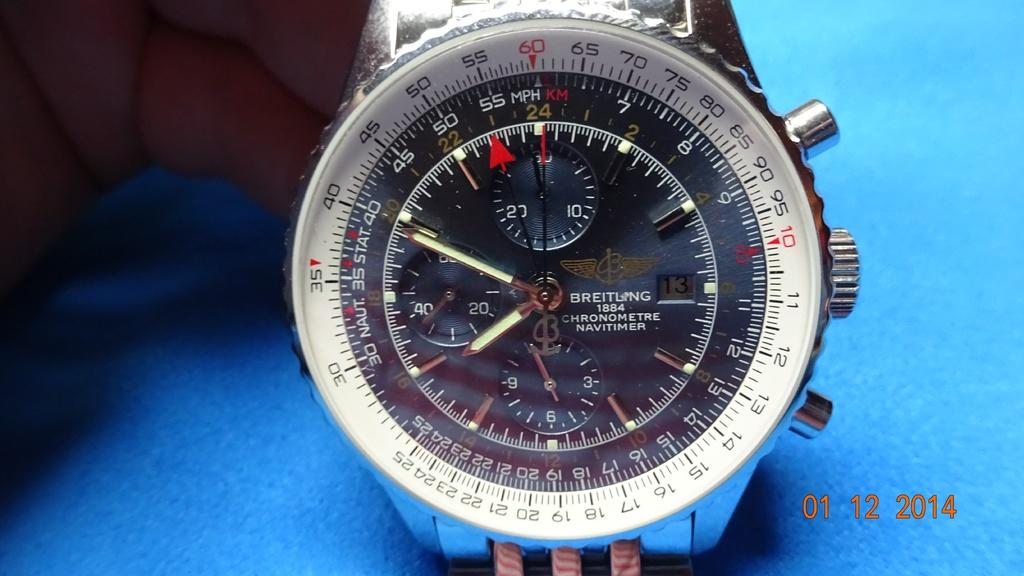<image>
Summarize the visual content of the image. A wrist watch that has a grey dial and is made by Breitling. 